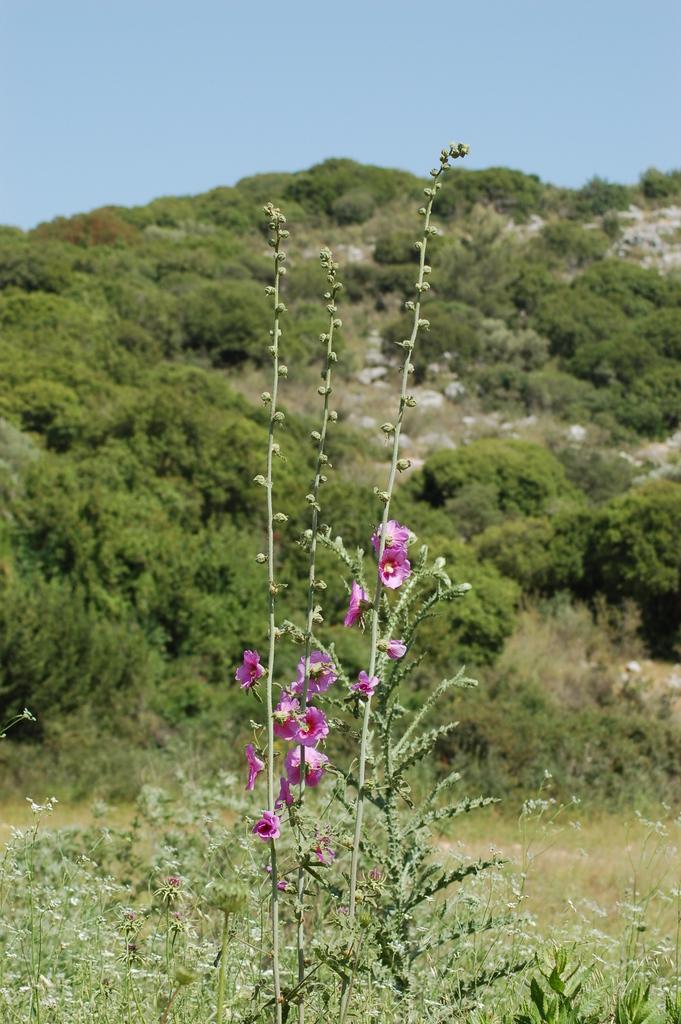Could you give a brief overview of what you see in this image? At the bottom of this image I can see some plants along with the flowers. In the background there are some trees and rocks. On the top of the image I can see the sky. 